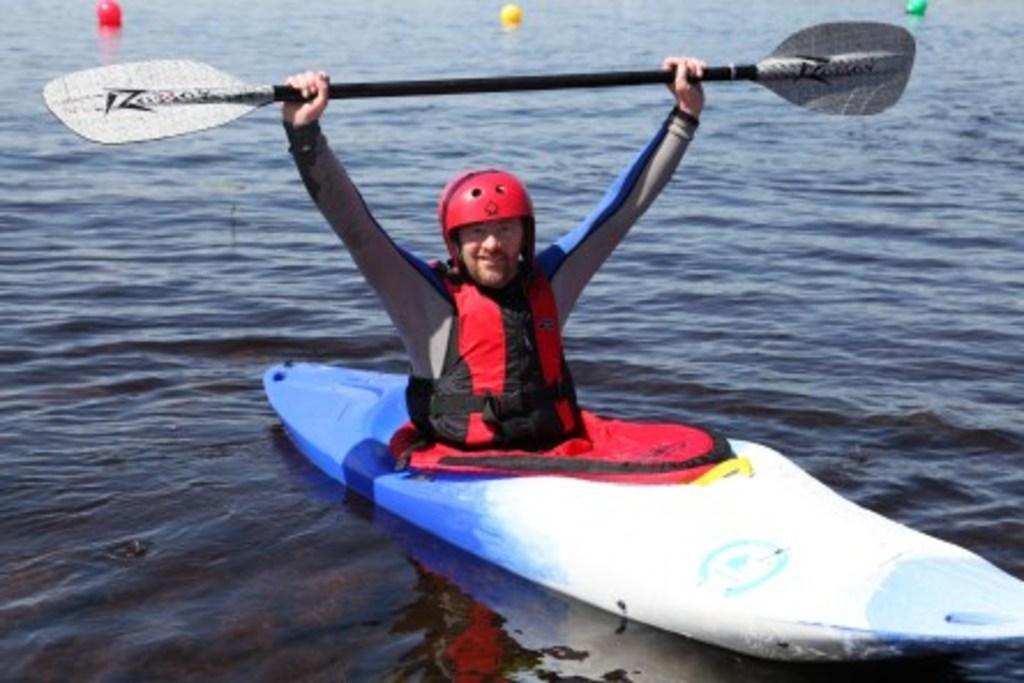Could you give a brief overview of what you see in this image? In this image we can see a man wearing the helmet and boating on the surface of the water. We can also see the man holding the paddle. In the background we can see the balls. 